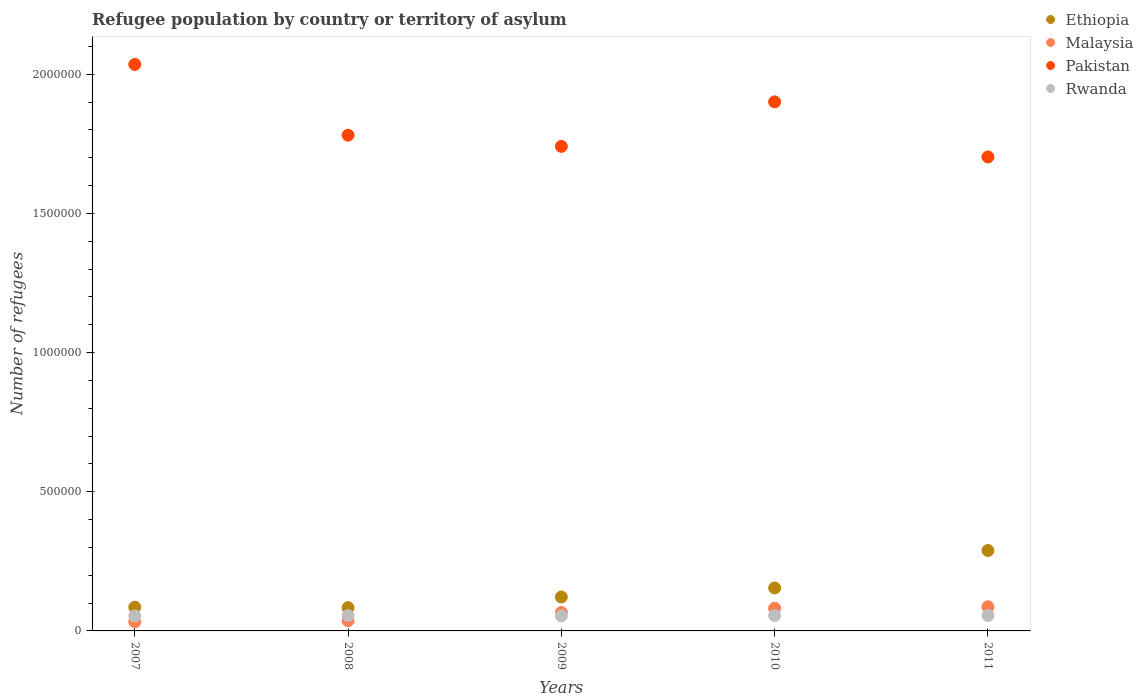How many different coloured dotlines are there?
Make the answer very short. 4. Is the number of dotlines equal to the number of legend labels?
Offer a terse response. Yes. What is the number of refugees in Rwanda in 2008?
Provide a succinct answer. 5.51e+04. Across all years, what is the maximum number of refugees in Pakistan?
Provide a short and direct response. 2.04e+06. Across all years, what is the minimum number of refugees in Malaysia?
Make the answer very short. 3.27e+04. What is the total number of refugees in Ethiopia in the graph?
Ensure brevity in your answer.  7.34e+05. What is the difference between the number of refugees in Rwanda in 2010 and that in 2011?
Give a very brief answer. 73. What is the difference between the number of refugees in Pakistan in 2008 and the number of refugees in Rwanda in 2009?
Your answer should be very brief. 1.73e+06. What is the average number of refugees in Pakistan per year?
Your answer should be very brief. 1.83e+06. In the year 2009, what is the difference between the number of refugees in Rwanda and number of refugees in Malaysia?
Your answer should be very brief. -1.21e+04. What is the ratio of the number of refugees in Malaysia in 2009 to that in 2011?
Give a very brief answer. 0.76. Is the number of refugees in Ethiopia in 2008 less than that in 2010?
Ensure brevity in your answer.  Yes. What is the difference between the highest and the second highest number of refugees in Rwanda?
Give a very brief answer. 73. What is the difference between the highest and the lowest number of refugees in Ethiopia?
Offer a terse response. 2.05e+05. In how many years, is the number of refugees in Malaysia greater than the average number of refugees in Malaysia taken over all years?
Your answer should be very brief. 3. Does the number of refugees in Malaysia monotonically increase over the years?
Provide a succinct answer. Yes. Is the number of refugees in Ethiopia strictly less than the number of refugees in Rwanda over the years?
Your answer should be very brief. No. How many years are there in the graph?
Ensure brevity in your answer.  5. What is the difference between two consecutive major ticks on the Y-axis?
Make the answer very short. 5.00e+05. Are the values on the major ticks of Y-axis written in scientific E-notation?
Your response must be concise. No. Does the graph contain grids?
Your response must be concise. No. How are the legend labels stacked?
Keep it short and to the point. Vertical. What is the title of the graph?
Your response must be concise. Refugee population by country or territory of asylum. What is the label or title of the X-axis?
Make the answer very short. Years. What is the label or title of the Y-axis?
Your answer should be compact. Number of refugees. What is the Number of refugees of Ethiopia in 2007?
Your answer should be very brief. 8.52e+04. What is the Number of refugees in Malaysia in 2007?
Provide a short and direct response. 3.27e+04. What is the Number of refugees of Pakistan in 2007?
Offer a terse response. 2.04e+06. What is the Number of refugees in Rwanda in 2007?
Ensure brevity in your answer.  5.36e+04. What is the Number of refugees in Ethiopia in 2008?
Ensure brevity in your answer.  8.36e+04. What is the Number of refugees in Malaysia in 2008?
Provide a succinct answer. 3.67e+04. What is the Number of refugees of Pakistan in 2008?
Your answer should be compact. 1.78e+06. What is the Number of refugees in Rwanda in 2008?
Your answer should be compact. 5.51e+04. What is the Number of refugees of Ethiopia in 2009?
Your answer should be very brief. 1.22e+05. What is the Number of refugees in Malaysia in 2009?
Your answer should be very brief. 6.61e+04. What is the Number of refugees of Pakistan in 2009?
Provide a short and direct response. 1.74e+06. What is the Number of refugees of Rwanda in 2009?
Your answer should be very brief. 5.40e+04. What is the Number of refugees in Ethiopia in 2010?
Your answer should be very brief. 1.54e+05. What is the Number of refugees in Malaysia in 2010?
Your response must be concise. 8.15e+04. What is the Number of refugees in Pakistan in 2010?
Provide a short and direct response. 1.90e+06. What is the Number of refugees in Rwanda in 2010?
Provide a succinct answer. 5.54e+04. What is the Number of refugees in Ethiopia in 2011?
Offer a very short reply. 2.89e+05. What is the Number of refugees of Malaysia in 2011?
Offer a terse response. 8.67e+04. What is the Number of refugees in Pakistan in 2011?
Your response must be concise. 1.70e+06. What is the Number of refugees in Rwanda in 2011?
Provide a succinct answer. 5.53e+04. Across all years, what is the maximum Number of refugees in Ethiopia?
Your answer should be compact. 2.89e+05. Across all years, what is the maximum Number of refugees in Malaysia?
Provide a short and direct response. 8.67e+04. Across all years, what is the maximum Number of refugees of Pakistan?
Give a very brief answer. 2.04e+06. Across all years, what is the maximum Number of refugees in Rwanda?
Your answer should be compact. 5.54e+04. Across all years, what is the minimum Number of refugees in Ethiopia?
Offer a very short reply. 8.36e+04. Across all years, what is the minimum Number of refugees in Malaysia?
Provide a short and direct response. 3.27e+04. Across all years, what is the minimum Number of refugees in Pakistan?
Provide a short and direct response. 1.70e+06. Across all years, what is the minimum Number of refugees of Rwanda?
Keep it short and to the point. 5.36e+04. What is the total Number of refugees of Ethiopia in the graph?
Offer a very short reply. 7.34e+05. What is the total Number of refugees in Malaysia in the graph?
Your answer should be compact. 3.04e+05. What is the total Number of refugees in Pakistan in the graph?
Your answer should be compact. 9.16e+06. What is the total Number of refugees of Rwanda in the graph?
Offer a terse response. 2.73e+05. What is the difference between the Number of refugees of Ethiopia in 2007 and that in 2008?
Offer a terse response. 1600. What is the difference between the Number of refugees of Malaysia in 2007 and that in 2008?
Ensure brevity in your answer.  -4013. What is the difference between the Number of refugees in Pakistan in 2007 and that in 2008?
Your answer should be very brief. 2.54e+05. What is the difference between the Number of refugees in Rwanda in 2007 and that in 2008?
Ensure brevity in your answer.  -1485. What is the difference between the Number of refugees of Ethiopia in 2007 and that in 2009?
Give a very brief answer. -3.67e+04. What is the difference between the Number of refugees in Malaysia in 2007 and that in 2009?
Provide a short and direct response. -3.35e+04. What is the difference between the Number of refugees of Pakistan in 2007 and that in 2009?
Keep it short and to the point. 2.94e+05. What is the difference between the Number of refugees in Rwanda in 2007 and that in 2009?
Provide a succinct answer. -439. What is the difference between the Number of refugees in Ethiopia in 2007 and that in 2010?
Provide a succinct answer. -6.91e+04. What is the difference between the Number of refugees in Malaysia in 2007 and that in 2010?
Keep it short and to the point. -4.89e+04. What is the difference between the Number of refugees of Pakistan in 2007 and that in 2010?
Ensure brevity in your answer.  1.34e+05. What is the difference between the Number of refugees of Rwanda in 2007 and that in 2010?
Your answer should be very brief. -1821. What is the difference between the Number of refugees of Ethiopia in 2007 and that in 2011?
Offer a terse response. -2.04e+05. What is the difference between the Number of refugees of Malaysia in 2007 and that in 2011?
Give a very brief answer. -5.40e+04. What is the difference between the Number of refugees in Pakistan in 2007 and that in 2011?
Offer a terse response. 3.32e+05. What is the difference between the Number of refugees in Rwanda in 2007 and that in 2011?
Your answer should be compact. -1748. What is the difference between the Number of refugees in Ethiopia in 2008 and that in 2009?
Keep it short and to the point. -3.83e+04. What is the difference between the Number of refugees of Malaysia in 2008 and that in 2009?
Provide a short and direct response. -2.95e+04. What is the difference between the Number of refugees in Pakistan in 2008 and that in 2009?
Make the answer very short. 4.02e+04. What is the difference between the Number of refugees in Rwanda in 2008 and that in 2009?
Offer a terse response. 1046. What is the difference between the Number of refugees in Ethiopia in 2008 and that in 2010?
Offer a very short reply. -7.07e+04. What is the difference between the Number of refugees of Malaysia in 2008 and that in 2010?
Your answer should be very brief. -4.48e+04. What is the difference between the Number of refugees of Pakistan in 2008 and that in 2010?
Offer a terse response. -1.20e+05. What is the difference between the Number of refugees in Rwanda in 2008 and that in 2010?
Offer a very short reply. -336. What is the difference between the Number of refugees in Ethiopia in 2008 and that in 2011?
Your answer should be very brief. -2.05e+05. What is the difference between the Number of refugees of Malaysia in 2008 and that in 2011?
Make the answer very short. -5.00e+04. What is the difference between the Number of refugees of Pakistan in 2008 and that in 2011?
Your answer should be compact. 7.82e+04. What is the difference between the Number of refugees in Rwanda in 2008 and that in 2011?
Provide a short and direct response. -263. What is the difference between the Number of refugees in Ethiopia in 2009 and that in 2010?
Provide a succinct answer. -3.24e+04. What is the difference between the Number of refugees of Malaysia in 2009 and that in 2010?
Your response must be concise. -1.54e+04. What is the difference between the Number of refugees in Pakistan in 2009 and that in 2010?
Offer a very short reply. -1.60e+05. What is the difference between the Number of refugees in Rwanda in 2009 and that in 2010?
Ensure brevity in your answer.  -1382. What is the difference between the Number of refugees of Ethiopia in 2009 and that in 2011?
Offer a very short reply. -1.67e+05. What is the difference between the Number of refugees in Malaysia in 2009 and that in 2011?
Offer a very short reply. -2.05e+04. What is the difference between the Number of refugees of Pakistan in 2009 and that in 2011?
Offer a very short reply. 3.80e+04. What is the difference between the Number of refugees in Rwanda in 2009 and that in 2011?
Your answer should be very brief. -1309. What is the difference between the Number of refugees of Ethiopia in 2010 and that in 2011?
Your answer should be very brief. -1.35e+05. What is the difference between the Number of refugees in Malaysia in 2010 and that in 2011?
Your response must be concise. -5164. What is the difference between the Number of refugees in Pakistan in 2010 and that in 2011?
Make the answer very short. 1.98e+05. What is the difference between the Number of refugees in Ethiopia in 2007 and the Number of refugees in Malaysia in 2008?
Make the answer very short. 4.85e+04. What is the difference between the Number of refugees in Ethiopia in 2007 and the Number of refugees in Pakistan in 2008?
Offer a terse response. -1.70e+06. What is the difference between the Number of refugees in Ethiopia in 2007 and the Number of refugees in Rwanda in 2008?
Ensure brevity in your answer.  3.01e+04. What is the difference between the Number of refugees of Malaysia in 2007 and the Number of refugees of Pakistan in 2008?
Your answer should be compact. -1.75e+06. What is the difference between the Number of refugees in Malaysia in 2007 and the Number of refugees in Rwanda in 2008?
Your response must be concise. -2.24e+04. What is the difference between the Number of refugees of Pakistan in 2007 and the Number of refugees of Rwanda in 2008?
Offer a very short reply. 1.98e+06. What is the difference between the Number of refugees of Ethiopia in 2007 and the Number of refugees of Malaysia in 2009?
Give a very brief answer. 1.90e+04. What is the difference between the Number of refugees in Ethiopia in 2007 and the Number of refugees in Pakistan in 2009?
Offer a very short reply. -1.66e+06. What is the difference between the Number of refugees of Ethiopia in 2007 and the Number of refugees of Rwanda in 2009?
Keep it short and to the point. 3.12e+04. What is the difference between the Number of refugees in Malaysia in 2007 and the Number of refugees in Pakistan in 2009?
Give a very brief answer. -1.71e+06. What is the difference between the Number of refugees of Malaysia in 2007 and the Number of refugees of Rwanda in 2009?
Ensure brevity in your answer.  -2.14e+04. What is the difference between the Number of refugees in Pakistan in 2007 and the Number of refugees in Rwanda in 2009?
Your response must be concise. 1.98e+06. What is the difference between the Number of refugees in Ethiopia in 2007 and the Number of refugees in Malaysia in 2010?
Offer a terse response. 3667. What is the difference between the Number of refugees in Ethiopia in 2007 and the Number of refugees in Pakistan in 2010?
Provide a short and direct response. -1.82e+06. What is the difference between the Number of refugees of Ethiopia in 2007 and the Number of refugees of Rwanda in 2010?
Provide a succinct answer. 2.98e+04. What is the difference between the Number of refugees of Malaysia in 2007 and the Number of refugees of Pakistan in 2010?
Ensure brevity in your answer.  -1.87e+06. What is the difference between the Number of refugees of Malaysia in 2007 and the Number of refugees of Rwanda in 2010?
Keep it short and to the point. -2.27e+04. What is the difference between the Number of refugees of Pakistan in 2007 and the Number of refugees of Rwanda in 2010?
Your response must be concise. 1.98e+06. What is the difference between the Number of refugees in Ethiopia in 2007 and the Number of refugees in Malaysia in 2011?
Offer a terse response. -1497. What is the difference between the Number of refugees in Ethiopia in 2007 and the Number of refugees in Pakistan in 2011?
Ensure brevity in your answer.  -1.62e+06. What is the difference between the Number of refugees in Ethiopia in 2007 and the Number of refugees in Rwanda in 2011?
Ensure brevity in your answer.  2.99e+04. What is the difference between the Number of refugees of Malaysia in 2007 and the Number of refugees of Pakistan in 2011?
Your response must be concise. -1.67e+06. What is the difference between the Number of refugees of Malaysia in 2007 and the Number of refugees of Rwanda in 2011?
Your answer should be compact. -2.27e+04. What is the difference between the Number of refugees in Pakistan in 2007 and the Number of refugees in Rwanda in 2011?
Provide a succinct answer. 1.98e+06. What is the difference between the Number of refugees in Ethiopia in 2008 and the Number of refugees in Malaysia in 2009?
Make the answer very short. 1.74e+04. What is the difference between the Number of refugees in Ethiopia in 2008 and the Number of refugees in Pakistan in 2009?
Give a very brief answer. -1.66e+06. What is the difference between the Number of refugees in Ethiopia in 2008 and the Number of refugees in Rwanda in 2009?
Give a very brief answer. 2.96e+04. What is the difference between the Number of refugees of Malaysia in 2008 and the Number of refugees of Pakistan in 2009?
Your answer should be compact. -1.70e+06. What is the difference between the Number of refugees of Malaysia in 2008 and the Number of refugees of Rwanda in 2009?
Your answer should be compact. -1.73e+04. What is the difference between the Number of refugees of Pakistan in 2008 and the Number of refugees of Rwanda in 2009?
Ensure brevity in your answer.  1.73e+06. What is the difference between the Number of refugees in Ethiopia in 2008 and the Number of refugees in Malaysia in 2010?
Offer a terse response. 2067. What is the difference between the Number of refugees in Ethiopia in 2008 and the Number of refugees in Pakistan in 2010?
Keep it short and to the point. -1.82e+06. What is the difference between the Number of refugees of Ethiopia in 2008 and the Number of refugees of Rwanda in 2010?
Offer a terse response. 2.82e+04. What is the difference between the Number of refugees in Malaysia in 2008 and the Number of refugees in Pakistan in 2010?
Give a very brief answer. -1.86e+06. What is the difference between the Number of refugees in Malaysia in 2008 and the Number of refugees in Rwanda in 2010?
Offer a terse response. -1.87e+04. What is the difference between the Number of refugees of Pakistan in 2008 and the Number of refugees of Rwanda in 2010?
Your response must be concise. 1.73e+06. What is the difference between the Number of refugees in Ethiopia in 2008 and the Number of refugees in Malaysia in 2011?
Provide a succinct answer. -3097. What is the difference between the Number of refugees in Ethiopia in 2008 and the Number of refugees in Pakistan in 2011?
Keep it short and to the point. -1.62e+06. What is the difference between the Number of refugees in Ethiopia in 2008 and the Number of refugees in Rwanda in 2011?
Your answer should be very brief. 2.83e+04. What is the difference between the Number of refugees in Malaysia in 2008 and the Number of refugees in Pakistan in 2011?
Your answer should be compact. -1.67e+06. What is the difference between the Number of refugees in Malaysia in 2008 and the Number of refugees in Rwanda in 2011?
Your answer should be compact. -1.87e+04. What is the difference between the Number of refugees of Pakistan in 2008 and the Number of refugees of Rwanda in 2011?
Offer a terse response. 1.73e+06. What is the difference between the Number of refugees in Ethiopia in 2009 and the Number of refugees in Malaysia in 2010?
Make the answer very short. 4.04e+04. What is the difference between the Number of refugees of Ethiopia in 2009 and the Number of refugees of Pakistan in 2010?
Your answer should be compact. -1.78e+06. What is the difference between the Number of refugees of Ethiopia in 2009 and the Number of refugees of Rwanda in 2010?
Your answer should be very brief. 6.65e+04. What is the difference between the Number of refugees of Malaysia in 2009 and the Number of refugees of Pakistan in 2010?
Keep it short and to the point. -1.83e+06. What is the difference between the Number of refugees of Malaysia in 2009 and the Number of refugees of Rwanda in 2010?
Offer a very short reply. 1.07e+04. What is the difference between the Number of refugees of Pakistan in 2009 and the Number of refugees of Rwanda in 2010?
Make the answer very short. 1.69e+06. What is the difference between the Number of refugees in Ethiopia in 2009 and the Number of refugees in Malaysia in 2011?
Offer a terse response. 3.52e+04. What is the difference between the Number of refugees in Ethiopia in 2009 and the Number of refugees in Pakistan in 2011?
Give a very brief answer. -1.58e+06. What is the difference between the Number of refugees in Ethiopia in 2009 and the Number of refugees in Rwanda in 2011?
Offer a very short reply. 6.66e+04. What is the difference between the Number of refugees of Malaysia in 2009 and the Number of refugees of Pakistan in 2011?
Provide a succinct answer. -1.64e+06. What is the difference between the Number of refugees in Malaysia in 2009 and the Number of refugees in Rwanda in 2011?
Give a very brief answer. 1.08e+04. What is the difference between the Number of refugees of Pakistan in 2009 and the Number of refugees of Rwanda in 2011?
Provide a short and direct response. 1.69e+06. What is the difference between the Number of refugees in Ethiopia in 2010 and the Number of refugees in Malaysia in 2011?
Keep it short and to the point. 6.76e+04. What is the difference between the Number of refugees of Ethiopia in 2010 and the Number of refugees of Pakistan in 2011?
Offer a terse response. -1.55e+06. What is the difference between the Number of refugees in Ethiopia in 2010 and the Number of refugees in Rwanda in 2011?
Give a very brief answer. 9.90e+04. What is the difference between the Number of refugees of Malaysia in 2010 and the Number of refugees of Pakistan in 2011?
Offer a very short reply. -1.62e+06. What is the difference between the Number of refugees of Malaysia in 2010 and the Number of refugees of Rwanda in 2011?
Keep it short and to the point. 2.62e+04. What is the difference between the Number of refugees in Pakistan in 2010 and the Number of refugees in Rwanda in 2011?
Offer a terse response. 1.85e+06. What is the average Number of refugees in Ethiopia per year?
Offer a very short reply. 1.47e+05. What is the average Number of refugees in Malaysia per year?
Offer a very short reply. 6.07e+04. What is the average Number of refugees of Pakistan per year?
Your answer should be compact. 1.83e+06. What is the average Number of refugees of Rwanda per year?
Ensure brevity in your answer.  5.47e+04. In the year 2007, what is the difference between the Number of refugees in Ethiopia and Number of refugees in Malaysia?
Offer a terse response. 5.25e+04. In the year 2007, what is the difference between the Number of refugees of Ethiopia and Number of refugees of Pakistan?
Offer a terse response. -1.95e+06. In the year 2007, what is the difference between the Number of refugees in Ethiopia and Number of refugees in Rwanda?
Your answer should be very brief. 3.16e+04. In the year 2007, what is the difference between the Number of refugees in Malaysia and Number of refugees in Pakistan?
Keep it short and to the point. -2.00e+06. In the year 2007, what is the difference between the Number of refugees of Malaysia and Number of refugees of Rwanda?
Keep it short and to the point. -2.09e+04. In the year 2007, what is the difference between the Number of refugees of Pakistan and Number of refugees of Rwanda?
Make the answer very short. 1.98e+06. In the year 2008, what is the difference between the Number of refugees in Ethiopia and Number of refugees in Malaysia?
Your answer should be very brief. 4.69e+04. In the year 2008, what is the difference between the Number of refugees in Ethiopia and Number of refugees in Pakistan?
Offer a terse response. -1.70e+06. In the year 2008, what is the difference between the Number of refugees in Ethiopia and Number of refugees in Rwanda?
Your answer should be compact. 2.85e+04. In the year 2008, what is the difference between the Number of refugees of Malaysia and Number of refugees of Pakistan?
Your answer should be compact. -1.74e+06. In the year 2008, what is the difference between the Number of refugees in Malaysia and Number of refugees in Rwanda?
Offer a very short reply. -1.84e+04. In the year 2008, what is the difference between the Number of refugees of Pakistan and Number of refugees of Rwanda?
Give a very brief answer. 1.73e+06. In the year 2009, what is the difference between the Number of refugees in Ethiopia and Number of refugees in Malaysia?
Offer a very short reply. 5.57e+04. In the year 2009, what is the difference between the Number of refugees in Ethiopia and Number of refugees in Pakistan?
Provide a succinct answer. -1.62e+06. In the year 2009, what is the difference between the Number of refugees of Ethiopia and Number of refugees of Rwanda?
Your answer should be compact. 6.79e+04. In the year 2009, what is the difference between the Number of refugees in Malaysia and Number of refugees in Pakistan?
Your answer should be very brief. -1.67e+06. In the year 2009, what is the difference between the Number of refugees of Malaysia and Number of refugees of Rwanda?
Give a very brief answer. 1.21e+04. In the year 2009, what is the difference between the Number of refugees of Pakistan and Number of refugees of Rwanda?
Offer a terse response. 1.69e+06. In the year 2010, what is the difference between the Number of refugees of Ethiopia and Number of refugees of Malaysia?
Your answer should be very brief. 7.28e+04. In the year 2010, what is the difference between the Number of refugees of Ethiopia and Number of refugees of Pakistan?
Offer a very short reply. -1.75e+06. In the year 2010, what is the difference between the Number of refugees in Ethiopia and Number of refugees in Rwanda?
Make the answer very short. 9.89e+04. In the year 2010, what is the difference between the Number of refugees of Malaysia and Number of refugees of Pakistan?
Your answer should be compact. -1.82e+06. In the year 2010, what is the difference between the Number of refugees in Malaysia and Number of refugees in Rwanda?
Your answer should be compact. 2.61e+04. In the year 2010, what is the difference between the Number of refugees in Pakistan and Number of refugees in Rwanda?
Give a very brief answer. 1.85e+06. In the year 2011, what is the difference between the Number of refugees in Ethiopia and Number of refugees in Malaysia?
Make the answer very short. 2.02e+05. In the year 2011, what is the difference between the Number of refugees in Ethiopia and Number of refugees in Pakistan?
Your answer should be very brief. -1.41e+06. In the year 2011, what is the difference between the Number of refugees in Ethiopia and Number of refugees in Rwanda?
Provide a succinct answer. 2.34e+05. In the year 2011, what is the difference between the Number of refugees in Malaysia and Number of refugees in Pakistan?
Provide a succinct answer. -1.62e+06. In the year 2011, what is the difference between the Number of refugees in Malaysia and Number of refugees in Rwanda?
Your answer should be very brief. 3.14e+04. In the year 2011, what is the difference between the Number of refugees of Pakistan and Number of refugees of Rwanda?
Give a very brief answer. 1.65e+06. What is the ratio of the Number of refugees in Ethiopia in 2007 to that in 2008?
Make the answer very short. 1.02. What is the ratio of the Number of refugees in Malaysia in 2007 to that in 2008?
Your response must be concise. 0.89. What is the ratio of the Number of refugees of Pakistan in 2007 to that in 2008?
Offer a terse response. 1.14. What is the ratio of the Number of refugees of Rwanda in 2007 to that in 2008?
Provide a short and direct response. 0.97. What is the ratio of the Number of refugees in Ethiopia in 2007 to that in 2009?
Ensure brevity in your answer.  0.7. What is the ratio of the Number of refugees of Malaysia in 2007 to that in 2009?
Offer a terse response. 0.49. What is the ratio of the Number of refugees in Pakistan in 2007 to that in 2009?
Your response must be concise. 1.17. What is the ratio of the Number of refugees of Ethiopia in 2007 to that in 2010?
Provide a short and direct response. 0.55. What is the ratio of the Number of refugees in Malaysia in 2007 to that in 2010?
Your response must be concise. 0.4. What is the ratio of the Number of refugees in Pakistan in 2007 to that in 2010?
Your response must be concise. 1.07. What is the ratio of the Number of refugees in Rwanda in 2007 to that in 2010?
Ensure brevity in your answer.  0.97. What is the ratio of the Number of refugees of Ethiopia in 2007 to that in 2011?
Your answer should be very brief. 0.29. What is the ratio of the Number of refugees of Malaysia in 2007 to that in 2011?
Give a very brief answer. 0.38. What is the ratio of the Number of refugees in Pakistan in 2007 to that in 2011?
Your answer should be compact. 1.2. What is the ratio of the Number of refugees in Rwanda in 2007 to that in 2011?
Your answer should be very brief. 0.97. What is the ratio of the Number of refugees in Ethiopia in 2008 to that in 2009?
Keep it short and to the point. 0.69. What is the ratio of the Number of refugees of Malaysia in 2008 to that in 2009?
Offer a very short reply. 0.55. What is the ratio of the Number of refugees of Pakistan in 2008 to that in 2009?
Offer a terse response. 1.02. What is the ratio of the Number of refugees in Rwanda in 2008 to that in 2009?
Offer a very short reply. 1.02. What is the ratio of the Number of refugees of Ethiopia in 2008 to that in 2010?
Your answer should be very brief. 0.54. What is the ratio of the Number of refugees in Malaysia in 2008 to that in 2010?
Make the answer very short. 0.45. What is the ratio of the Number of refugees in Pakistan in 2008 to that in 2010?
Your response must be concise. 0.94. What is the ratio of the Number of refugees of Rwanda in 2008 to that in 2010?
Make the answer very short. 0.99. What is the ratio of the Number of refugees in Ethiopia in 2008 to that in 2011?
Provide a succinct answer. 0.29. What is the ratio of the Number of refugees of Malaysia in 2008 to that in 2011?
Offer a very short reply. 0.42. What is the ratio of the Number of refugees in Pakistan in 2008 to that in 2011?
Provide a short and direct response. 1.05. What is the ratio of the Number of refugees of Rwanda in 2008 to that in 2011?
Give a very brief answer. 1. What is the ratio of the Number of refugees in Ethiopia in 2009 to that in 2010?
Keep it short and to the point. 0.79. What is the ratio of the Number of refugees in Malaysia in 2009 to that in 2010?
Your answer should be very brief. 0.81. What is the ratio of the Number of refugees in Pakistan in 2009 to that in 2010?
Offer a terse response. 0.92. What is the ratio of the Number of refugees in Rwanda in 2009 to that in 2010?
Your answer should be very brief. 0.98. What is the ratio of the Number of refugees of Ethiopia in 2009 to that in 2011?
Make the answer very short. 0.42. What is the ratio of the Number of refugees in Malaysia in 2009 to that in 2011?
Your answer should be very brief. 0.76. What is the ratio of the Number of refugees in Pakistan in 2009 to that in 2011?
Make the answer very short. 1.02. What is the ratio of the Number of refugees in Rwanda in 2009 to that in 2011?
Make the answer very short. 0.98. What is the ratio of the Number of refugees of Ethiopia in 2010 to that in 2011?
Your answer should be compact. 0.53. What is the ratio of the Number of refugees of Malaysia in 2010 to that in 2011?
Ensure brevity in your answer.  0.94. What is the ratio of the Number of refugees of Pakistan in 2010 to that in 2011?
Ensure brevity in your answer.  1.12. What is the ratio of the Number of refugees of Rwanda in 2010 to that in 2011?
Offer a terse response. 1. What is the difference between the highest and the second highest Number of refugees of Ethiopia?
Ensure brevity in your answer.  1.35e+05. What is the difference between the highest and the second highest Number of refugees of Malaysia?
Ensure brevity in your answer.  5164. What is the difference between the highest and the second highest Number of refugees of Pakistan?
Keep it short and to the point. 1.34e+05. What is the difference between the highest and the second highest Number of refugees of Rwanda?
Keep it short and to the point. 73. What is the difference between the highest and the lowest Number of refugees of Ethiopia?
Ensure brevity in your answer.  2.05e+05. What is the difference between the highest and the lowest Number of refugees in Malaysia?
Provide a short and direct response. 5.40e+04. What is the difference between the highest and the lowest Number of refugees in Pakistan?
Ensure brevity in your answer.  3.32e+05. What is the difference between the highest and the lowest Number of refugees of Rwanda?
Offer a very short reply. 1821. 